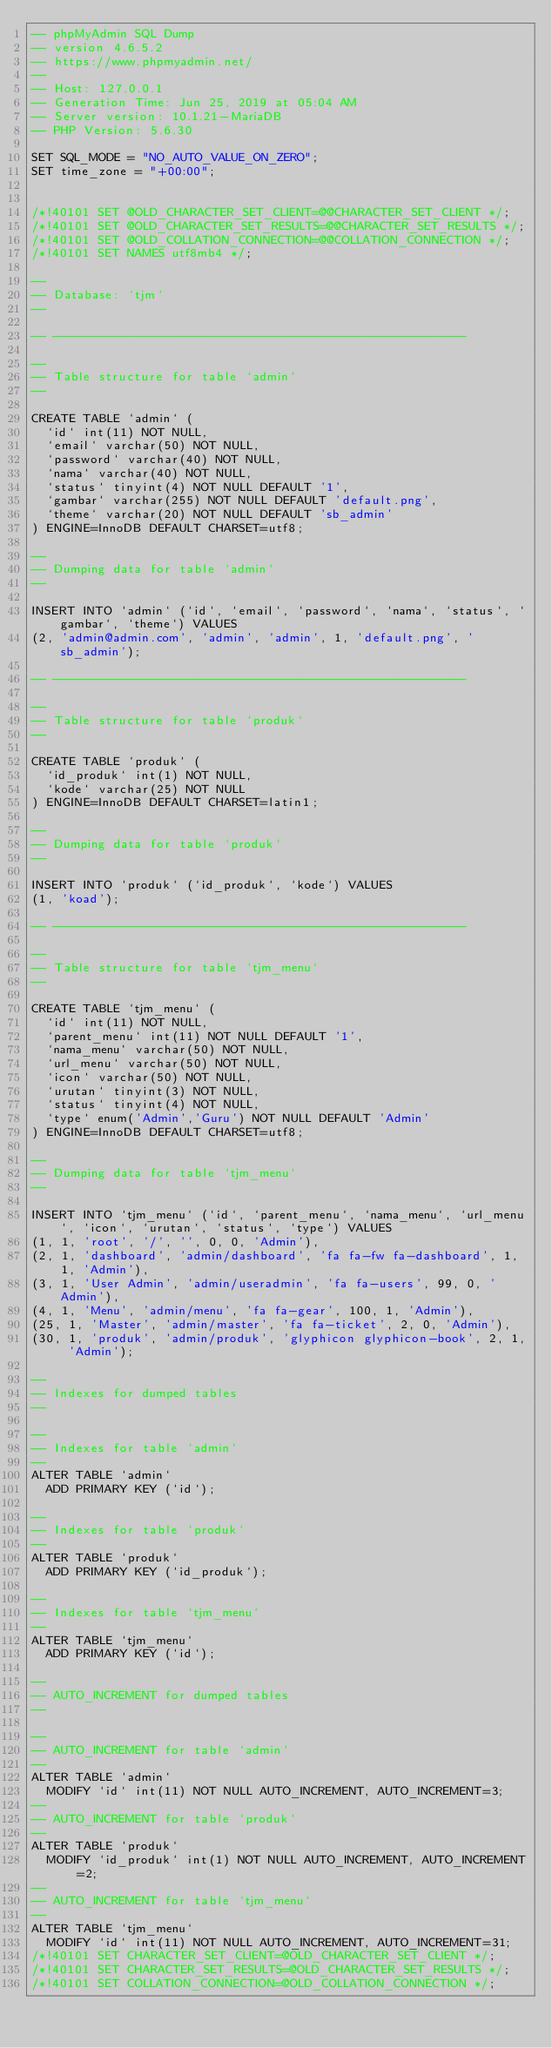Convert code to text. <code><loc_0><loc_0><loc_500><loc_500><_SQL_>-- phpMyAdmin SQL Dump
-- version 4.6.5.2
-- https://www.phpmyadmin.net/
--
-- Host: 127.0.0.1
-- Generation Time: Jun 25, 2019 at 05:04 AM
-- Server version: 10.1.21-MariaDB
-- PHP Version: 5.6.30

SET SQL_MODE = "NO_AUTO_VALUE_ON_ZERO";
SET time_zone = "+00:00";


/*!40101 SET @OLD_CHARACTER_SET_CLIENT=@@CHARACTER_SET_CLIENT */;
/*!40101 SET @OLD_CHARACTER_SET_RESULTS=@@CHARACTER_SET_RESULTS */;
/*!40101 SET @OLD_COLLATION_CONNECTION=@@COLLATION_CONNECTION */;
/*!40101 SET NAMES utf8mb4 */;

--
-- Database: `tjm`
--

-- --------------------------------------------------------

--
-- Table structure for table `admin`
--

CREATE TABLE `admin` (
  `id` int(11) NOT NULL,
  `email` varchar(50) NOT NULL,
  `password` varchar(40) NOT NULL,
  `nama` varchar(40) NOT NULL,
  `status` tinyint(4) NOT NULL DEFAULT '1',
  `gambar` varchar(255) NOT NULL DEFAULT 'default.png',
  `theme` varchar(20) NOT NULL DEFAULT 'sb_admin'
) ENGINE=InnoDB DEFAULT CHARSET=utf8;

--
-- Dumping data for table `admin`
--

INSERT INTO `admin` (`id`, `email`, `password`, `nama`, `status`, `gambar`, `theme`) VALUES
(2, 'admin@admin.com', 'admin', 'admin', 1, 'default.png', 'sb_admin');

-- --------------------------------------------------------

--
-- Table structure for table `produk`
--

CREATE TABLE `produk` (
  `id_produk` int(1) NOT NULL,
  `kode` varchar(25) NOT NULL
) ENGINE=InnoDB DEFAULT CHARSET=latin1;

--
-- Dumping data for table `produk`
--

INSERT INTO `produk` (`id_produk`, `kode`) VALUES
(1, 'koad');

-- --------------------------------------------------------

--
-- Table structure for table `tjm_menu`
--

CREATE TABLE `tjm_menu` (
  `id` int(11) NOT NULL,
  `parent_menu` int(11) NOT NULL DEFAULT '1',
  `nama_menu` varchar(50) NOT NULL,
  `url_menu` varchar(50) NOT NULL,
  `icon` varchar(50) NOT NULL,
  `urutan` tinyint(3) NOT NULL,
  `status` tinyint(4) NOT NULL,
  `type` enum('Admin','Guru') NOT NULL DEFAULT 'Admin'
) ENGINE=InnoDB DEFAULT CHARSET=utf8;

--
-- Dumping data for table `tjm_menu`
--

INSERT INTO `tjm_menu` (`id`, `parent_menu`, `nama_menu`, `url_menu`, `icon`, `urutan`, `status`, `type`) VALUES
(1, 1, 'root', '/', '', 0, 0, 'Admin'),
(2, 1, 'dashboard', 'admin/dashboard', 'fa fa-fw fa-dashboard', 1, 1, 'Admin'),
(3, 1, 'User Admin', 'admin/useradmin', 'fa fa-users', 99, 0, 'Admin'),
(4, 1, 'Menu', 'admin/menu', 'fa fa-gear', 100, 1, 'Admin'),
(25, 1, 'Master', 'admin/master', 'fa fa-ticket', 2, 0, 'Admin'),
(30, 1, 'produk', 'admin/produk', 'glyphicon glyphicon-book', 2, 1, 'Admin');

--
-- Indexes for dumped tables
--

--
-- Indexes for table `admin`
--
ALTER TABLE `admin`
  ADD PRIMARY KEY (`id`);

--
-- Indexes for table `produk`
--
ALTER TABLE `produk`
  ADD PRIMARY KEY (`id_produk`);

--
-- Indexes for table `tjm_menu`
--
ALTER TABLE `tjm_menu`
  ADD PRIMARY KEY (`id`);

--
-- AUTO_INCREMENT for dumped tables
--

--
-- AUTO_INCREMENT for table `admin`
--
ALTER TABLE `admin`
  MODIFY `id` int(11) NOT NULL AUTO_INCREMENT, AUTO_INCREMENT=3;
--
-- AUTO_INCREMENT for table `produk`
--
ALTER TABLE `produk`
  MODIFY `id_produk` int(1) NOT NULL AUTO_INCREMENT, AUTO_INCREMENT=2;
--
-- AUTO_INCREMENT for table `tjm_menu`
--
ALTER TABLE `tjm_menu`
  MODIFY `id` int(11) NOT NULL AUTO_INCREMENT, AUTO_INCREMENT=31;
/*!40101 SET CHARACTER_SET_CLIENT=@OLD_CHARACTER_SET_CLIENT */;
/*!40101 SET CHARACTER_SET_RESULTS=@OLD_CHARACTER_SET_RESULTS */;
/*!40101 SET COLLATION_CONNECTION=@OLD_COLLATION_CONNECTION */;
</code> 